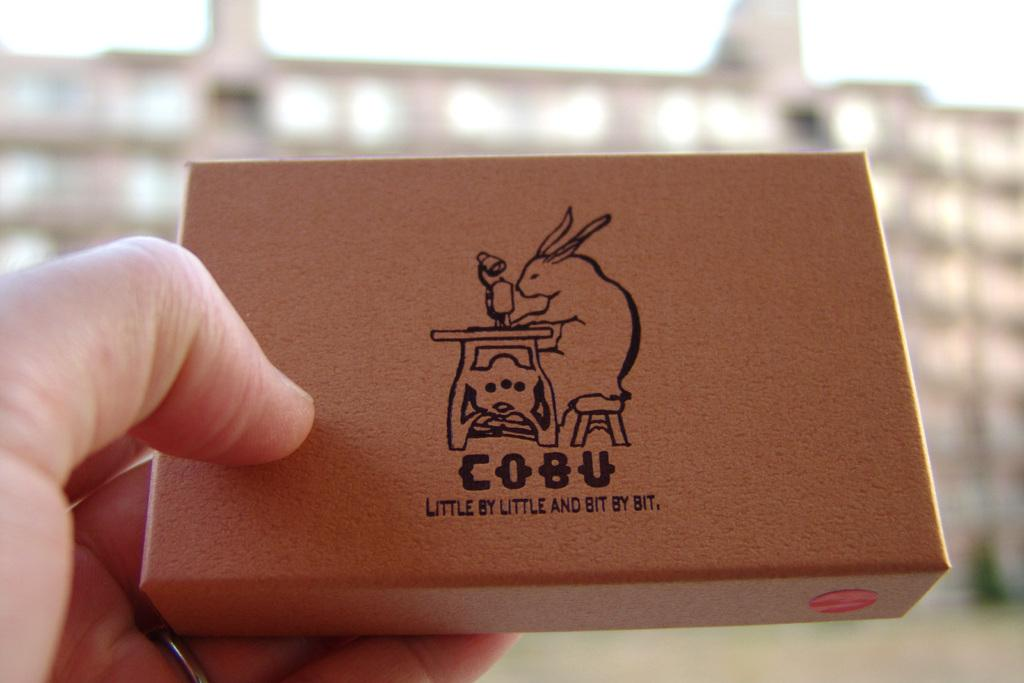<image>
Describe the image concisely. The brown box shows the saying little by little bit by bit. 